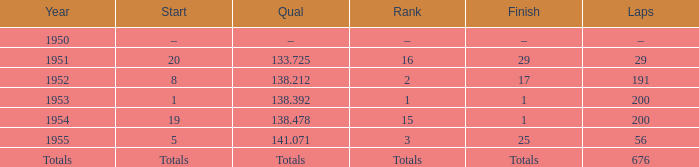Give me the full table as a dictionary. {'header': ['Year', 'Start', 'Qual', 'Rank', 'Finish', 'Laps'], 'rows': [['1950', '–', '–', '–', '–', '–'], ['1951', '20', '133.725', '16', '29', '29'], ['1952', '8', '138.212', '2', '17', '191'], ['1953', '1', '138.392', '1', '1', '200'], ['1954', '19', '138.478', '15', '1', '200'], ['1955', '5', '141.071', '3', '25', '56'], ['Totals', 'Totals', 'Totals', 'Totals', 'Totals', '676']]} What completion attained at 14 25.0. 